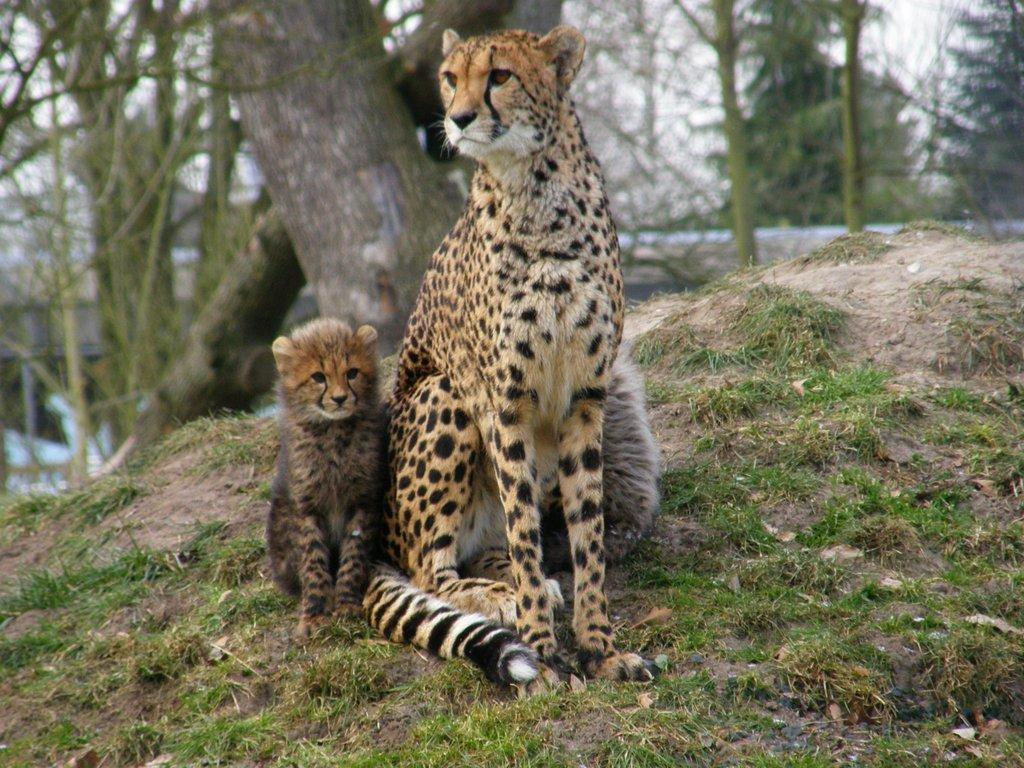What is in the foreground of the image? There are two animals in the foreground of the image. What is the surface the animals are standing on? The animals are on grass. What can be seen in the background of the image? There are trees, water, and the sky visible in the background of the image. What type of environment might the image depict? The image might have been taken in a forest. How many beetles are visible in the image? There are no beetles visible in the image; it features two animals on grass with trees, water, and the sky in the background. What mathematical operation is being performed in the image? There is no mathematical operation being performed in the image; it is a photograph of two animals in a natural setting. 